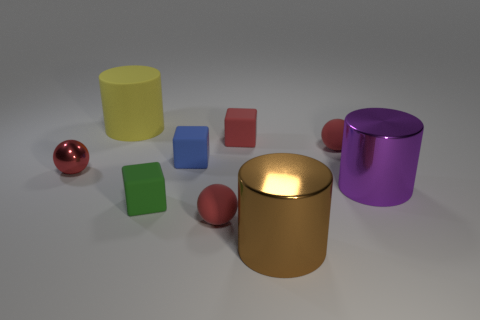What size is the block that is the same color as the tiny metallic object?
Offer a terse response. Small. How many other objects are the same color as the tiny metal thing?
Provide a succinct answer. 3. Is there a large brown object behind the matte object to the right of the shiny cylinder in front of the tiny green rubber object?
Your answer should be very brief. No. How many rubber things are red cubes or small balls?
Your answer should be very brief. 3. How many tiny red metal objects are to the right of the large purple shiny thing?
Offer a very short reply. 0. How many red things are behind the green rubber block and on the right side of the matte cylinder?
Your response must be concise. 2. The other big object that is the same material as the blue object is what shape?
Offer a very short reply. Cylinder. Do the cylinder that is left of the small green block and the shiny cylinder that is in front of the green thing have the same size?
Your answer should be compact. Yes. There is a small rubber sphere on the right side of the brown thing; what is its color?
Offer a very short reply. Red. What material is the cylinder that is in front of the red rubber object that is in front of the purple cylinder?
Make the answer very short. Metal. 